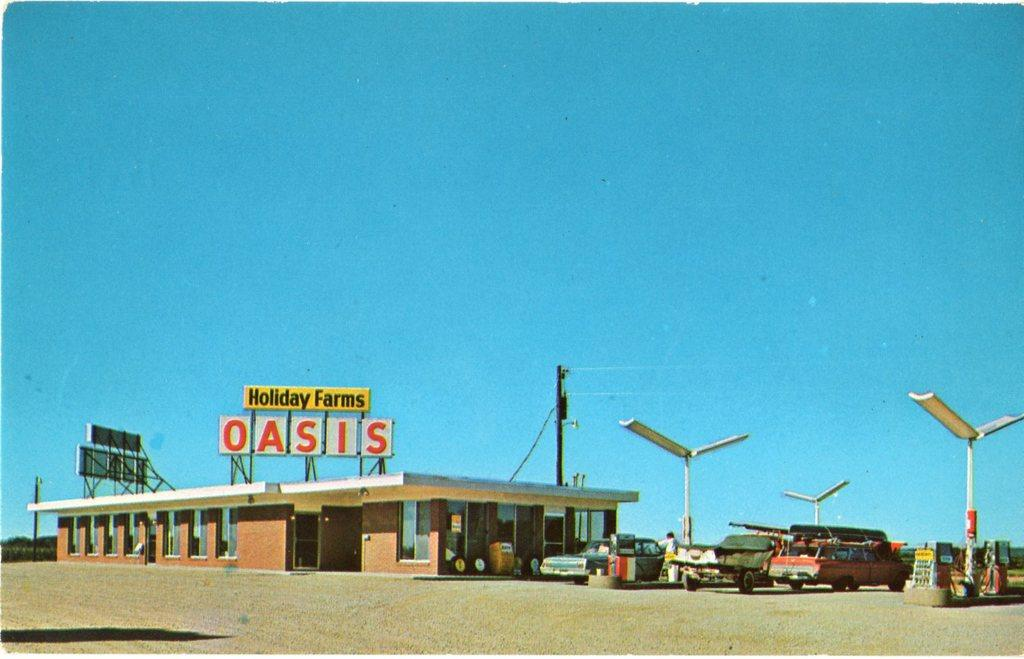What type of structure is located at the bottom of the image? There is a house at the bottom of the image. What objects can be seen in the image that are used for support or suspension? There are poles in the image. What types of transportation are present in the image? There are vehicles in the image. Are there any people visible in the image? Yes, there are people in the image. What type of establishment can be seen in the image? There is an oil filling station in the image. What can be seen in the background of the image? The sky is visible in the background of the image. How many pizzas are being held by the thumb in the image? There are no pizzas or thumbs present in the image. 